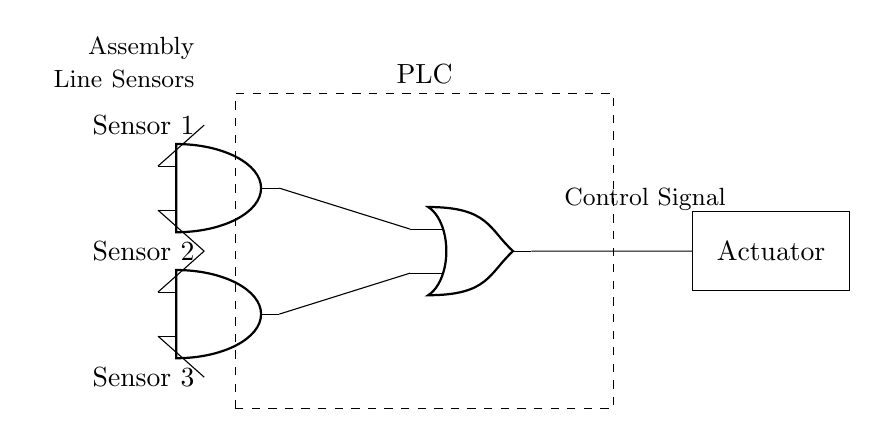What is the type of the output component? The output component is labeled as "Actuator," which is typically used to perform actions based on control signals.
Answer: Actuator How many input sensors are there? The diagram shows three sensors labeled as Sensor 1, Sensor 2, and Sensor 3, all positioned on the left side.
Answer: Three What type of logic gates are used in this circuit? The circuit includes AND gates and an OR gate, which are standard types of combinational logic gates used in digital circuits.
Answer: AND and OR What is the function of the AND gates in this circuit? The AND gates process the inputs from the sensors; they output a high signal only when all their inputs are high, which indicates certain conditions are met.
Answer: To process sensor inputs How do the AND gates connect to the OR gate? The output of the first AND gate is connected to one input of the OR gate, and the output of the second AND gate is connected to another input of the same OR gate, allowing any high output from the AND gates to trigger the OR gate.
Answer: Through direct connections If both Sensor 1 and Sensor 2 are activated, what happens at the actuator output? When both Sensor 1 and Sensor 2 are active, the first AND gate would output a high signal, which would then be sent to the OR gate; thus, the actuator will activate as the OR gate will output high.
Answer: The actuator activates How many AND gates are in the circuit? There are two AND gates present in the circuit as reflected in their labeled positions in the diagram.
Answer: Two 